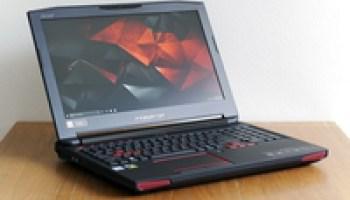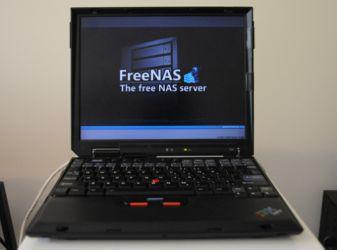The first image is the image on the left, the second image is the image on the right. For the images shown, is this caption "Both images contain no more than one laptop." true? Answer yes or no. Yes. The first image is the image on the left, the second image is the image on the right. Given the left and right images, does the statement "Multiple laptops have the same blue screen showing." hold true? Answer yes or no. No. 